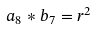Convert formula to latex. <formula><loc_0><loc_0><loc_500><loc_500>a _ { 8 } * b _ { 7 } = r ^ { 2 }</formula> 